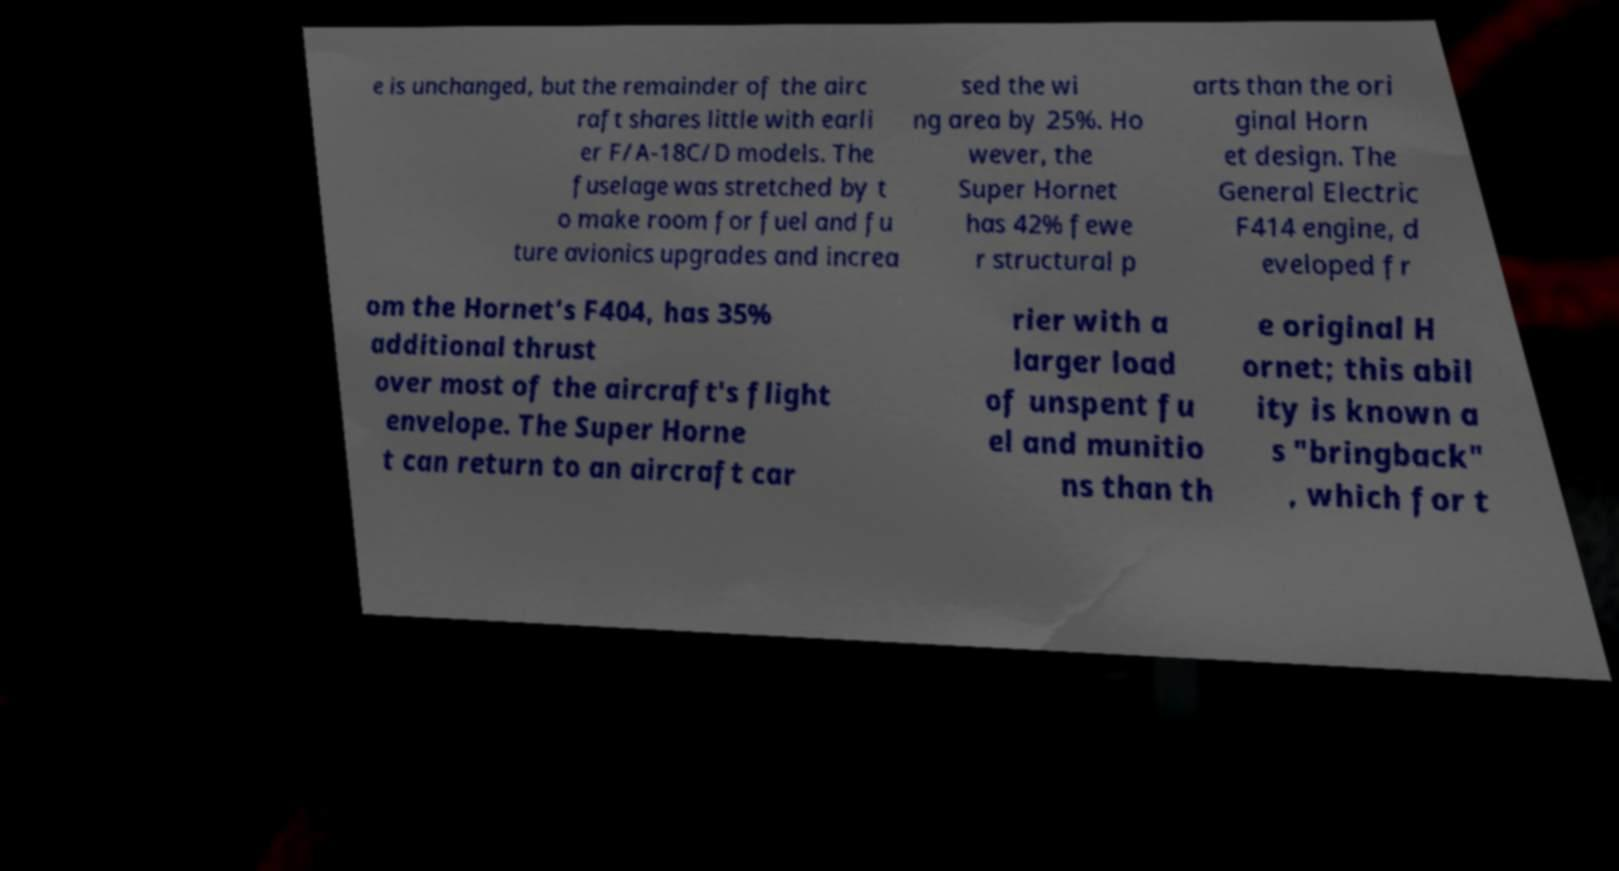Please read and relay the text visible in this image. What does it say? e is unchanged, but the remainder of the airc raft shares little with earli er F/A-18C/D models. The fuselage was stretched by t o make room for fuel and fu ture avionics upgrades and increa sed the wi ng area by 25%. Ho wever, the Super Hornet has 42% fewe r structural p arts than the ori ginal Horn et design. The General Electric F414 engine, d eveloped fr om the Hornet's F404, has 35% additional thrust over most of the aircraft's flight envelope. The Super Horne t can return to an aircraft car rier with a larger load of unspent fu el and munitio ns than th e original H ornet; this abil ity is known a s "bringback" , which for t 